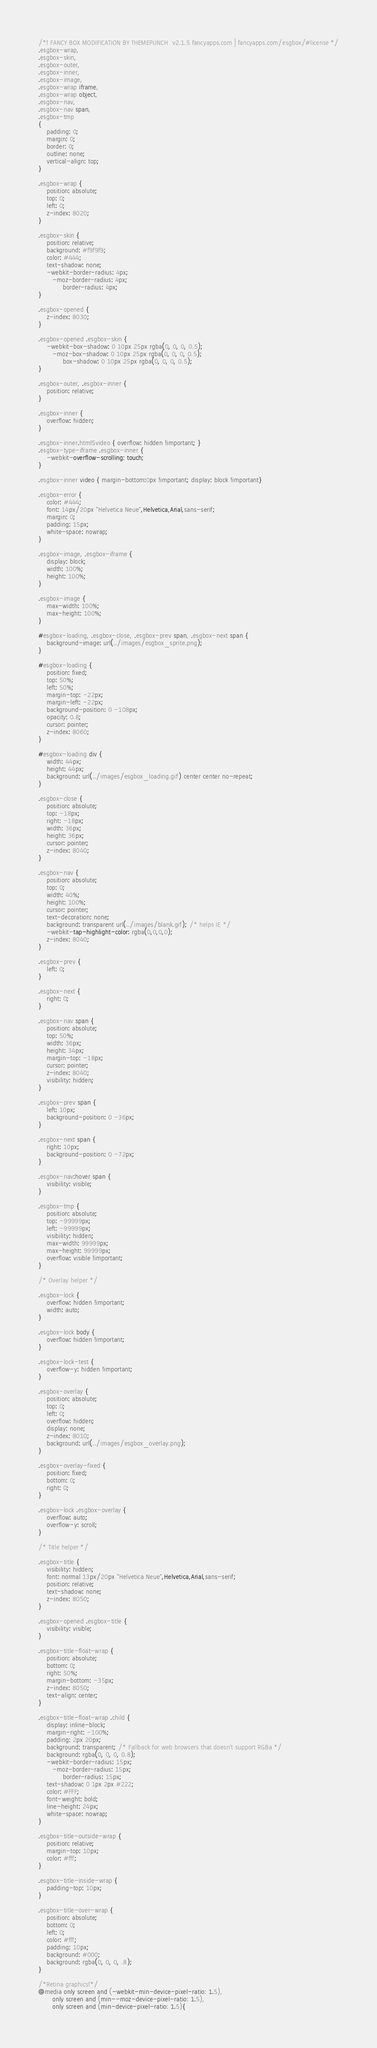<code> <loc_0><loc_0><loc_500><loc_500><_CSS_>/*! FANCY BOX MODIFICATION BY THEMEPUNCH  v2.1.5 fancyapps.com | fancyapps.com/esgbox/#license */
.esgbox-wrap,
.esgbox-skin,
.esgbox-outer,
.esgbox-inner,
.esgbox-image,
.esgbox-wrap iframe,
.esgbox-wrap object,
.esgbox-nav,
.esgbox-nav span,
.esgbox-tmp
{
	padding: 0;
	margin: 0;
	border: 0;
	outline: none;
	vertical-align: top;
}

.esgbox-wrap {
	position: absolute;
	top: 0;
	left: 0;
	z-index: 8020;
}

.esgbox-skin {
	position: relative;
	background: #f9f9f9;
	color: #444;
	text-shadow: none;
	-webkit-border-radius: 4px;
	   -moz-border-radius: 4px;
	        border-radius: 4px;
}

.esgbox-opened {
	z-index: 8030;
}

.esgbox-opened .esgbox-skin {
	-webkit-box-shadow: 0 10px 25px rgba(0, 0, 0, 0.5);
	   -moz-box-shadow: 0 10px 25px rgba(0, 0, 0, 0.5);
	        box-shadow: 0 10px 25px rgba(0, 0, 0, 0.5);
}

.esgbox-outer, .esgbox-inner {
	position: relative;
}

.esgbox-inner {
	overflow: hidden;
}

.esgbox-inner.html5video { overflow: hidden !important; }
.esgbox-type-iframe .esgbox-inner {
	-webkit-overflow-scrolling: touch;
}

.esgbox-inner video { margin-bottom:0px !important; display: block !important}

.esgbox-error {
	color: #444;
	font: 14px/20px "Helvetica Neue",Helvetica,Arial,sans-serif;
	margin: 0;
	padding: 15px;
	white-space: nowrap;
}

.esgbox-image, .esgbox-iframe {
	display: block;
	width: 100%;
	height: 100%;
}

.esgbox-image {
	max-width: 100%;
	max-height: 100%;
}

#esgbox-loading, .esgbox-close, .esgbox-prev span, .esgbox-next span {
	background-image: url(../images/esgbox_sprite.png);
}

#esgbox-loading {
	position: fixed;
	top: 50%;
	left: 50%;
	margin-top: -22px;
	margin-left: -22px;
	background-position: 0 -108px;
	opacity: 0.8;
	cursor: pointer;
	z-index: 8060;
}

#esgbox-loading div {
	width: 44px;
	height: 44px;
	background: url(../images/esgbox_loading.gif) center center no-repeat;
}

.esgbox-close {
	position: absolute;
	top: -18px;
	right: -18px;
	width: 36px;
	height: 36px;
	cursor: pointer;
	z-index: 8040;
}

.esgbox-nav {
	position: absolute;
	top: 0;
	width: 40%;
	height: 100%;
	cursor: pointer;
	text-decoration: none;
	background: transparent url(../images/blank.gif); /* helps IE */
	-webkit-tap-highlight-color: rgba(0,0,0,0);
	z-index: 8040;
}

.esgbox-prev {
	left: 0;
}

.esgbox-next {
	right: 0;
}

.esgbox-nav span {
	position: absolute;
	top: 50%;
	width: 36px;
	height: 34px;
	margin-top: -18px;
	cursor: pointer;
	z-index: 8040;
	visibility: hidden;
}

.esgbox-prev span {
	left: 10px;
	background-position: 0 -36px;
}

.esgbox-next span {
	right: 10px;
	background-position: 0 -72px;
}

.esgbox-nav:hover span {
	visibility: visible;
}

.esgbox-tmp {
	position: absolute;
	top: -99999px;
	left: -99999px;
	visibility: hidden;
	max-width: 99999px;
	max-height: 99999px;
	overflow: visible !important;
}

/* Overlay helper */

.esgbox-lock {
    overflow: hidden !important;
    width: auto;
}

.esgbox-lock body {
    overflow: hidden !important;
}

.esgbox-lock-test {
    overflow-y: hidden !important;
}

.esgbox-overlay {
	position: absolute;
	top: 0;
	left: 0;
	overflow: hidden;
	display: none;
	z-index: 8010;
	background: url(../images/esgbox_overlay.png);
}

.esgbox-overlay-fixed {
	position: fixed;
	bottom: 0;
	right: 0;
}

.esgbox-lock .esgbox-overlay {
	overflow: auto;
	overflow-y: scroll;
}

/* Title helper */

.esgbox-title {
	visibility: hidden;
	font: normal 13px/20px "Helvetica Neue",Helvetica,Arial,sans-serif;
	position: relative;
	text-shadow: none;
	z-index: 8050;
}

.esgbox-opened .esgbox-title {
	visibility: visible;
}

.esgbox-title-float-wrap {
	position: absolute;
	bottom: 0;
	right: 50%;
	margin-bottom: -35px;
	z-index: 8050;
	text-align: center;
}

.esgbox-title-float-wrap .child {
	display: inline-block;
	margin-right: -100%;
	padding: 2px 20px;
	background: transparent; /* Fallback for web browsers that doesn't support RGBa */
	background: rgba(0, 0, 0, 0.8);
	-webkit-border-radius: 15px;
	   -moz-border-radius: 15px;
	        border-radius: 15px;
	text-shadow: 0 1px 2px #222;
	color: #FFF;
	font-weight: bold;
	line-height: 24px;
	white-space: nowrap;
}

.esgbox-title-outside-wrap {
	position: relative;
	margin-top: 10px;
	color: #fff;
}

.esgbox-title-inside-wrap {
	padding-top: 10px;
}

.esgbox-title-over-wrap {
	position: absolute;
	bottom: 0;
	left: 0;
	color: #fff;
	padding: 10px;
	background: #000;
	background: rgba(0, 0, 0, .8);
}

/*Retina graphics!*/
@media only screen and (-webkit-min-device-pixel-ratio: 1.5),
	   only screen and (min--moz-device-pixel-ratio: 1.5),
	   only screen and (min-device-pixel-ratio: 1.5){
</code> 